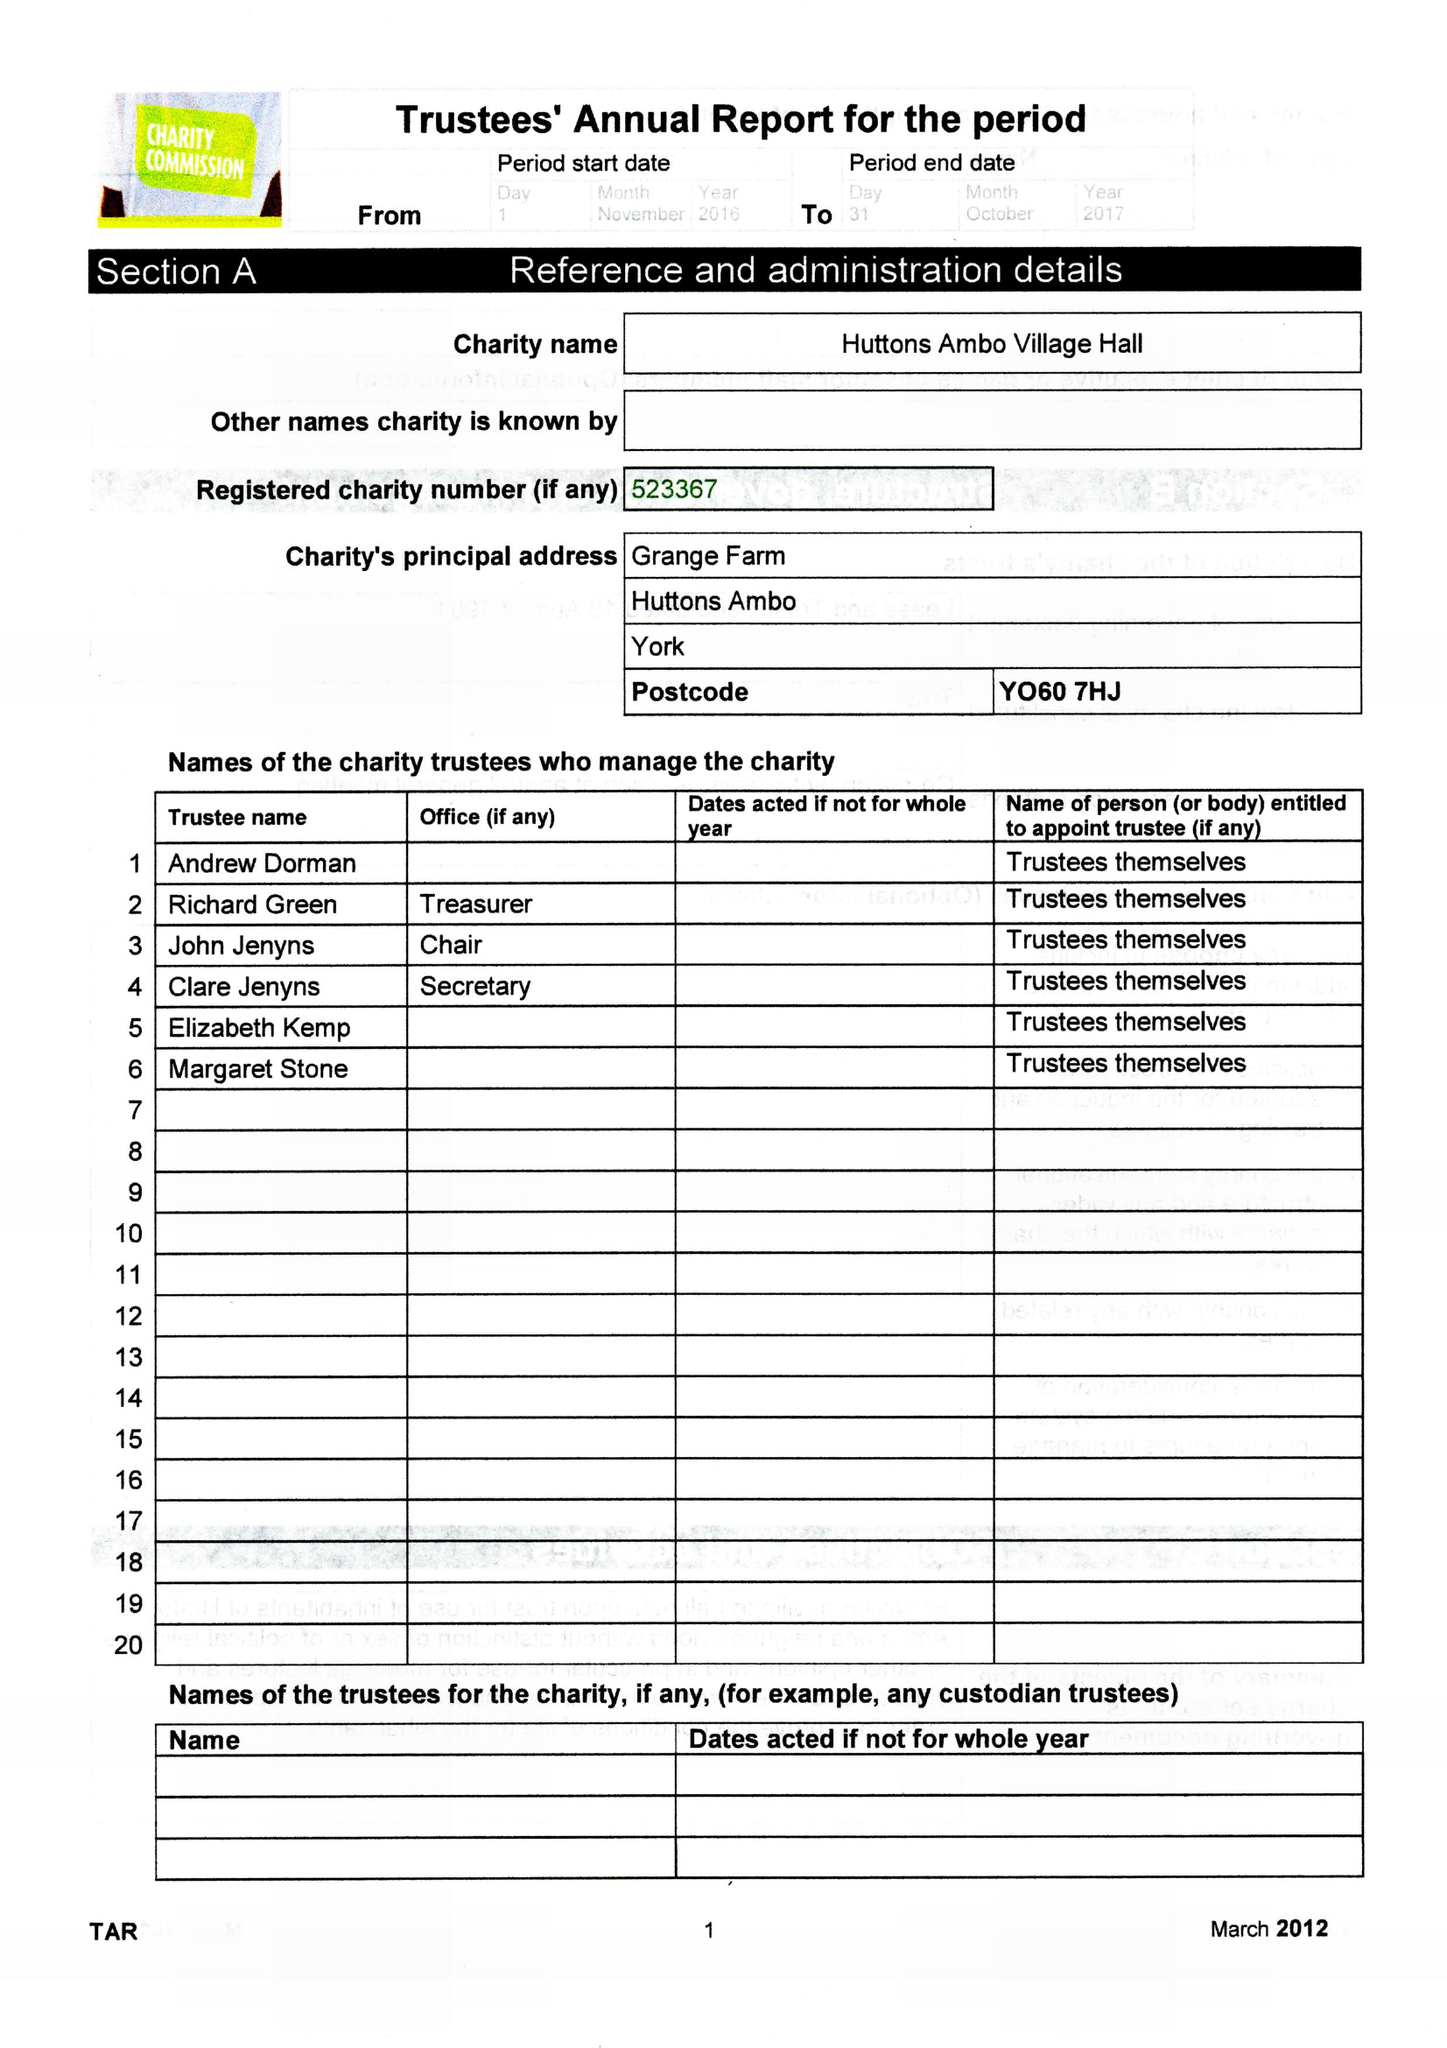What is the value for the charity_number?
Answer the question using a single word or phrase. 523367 